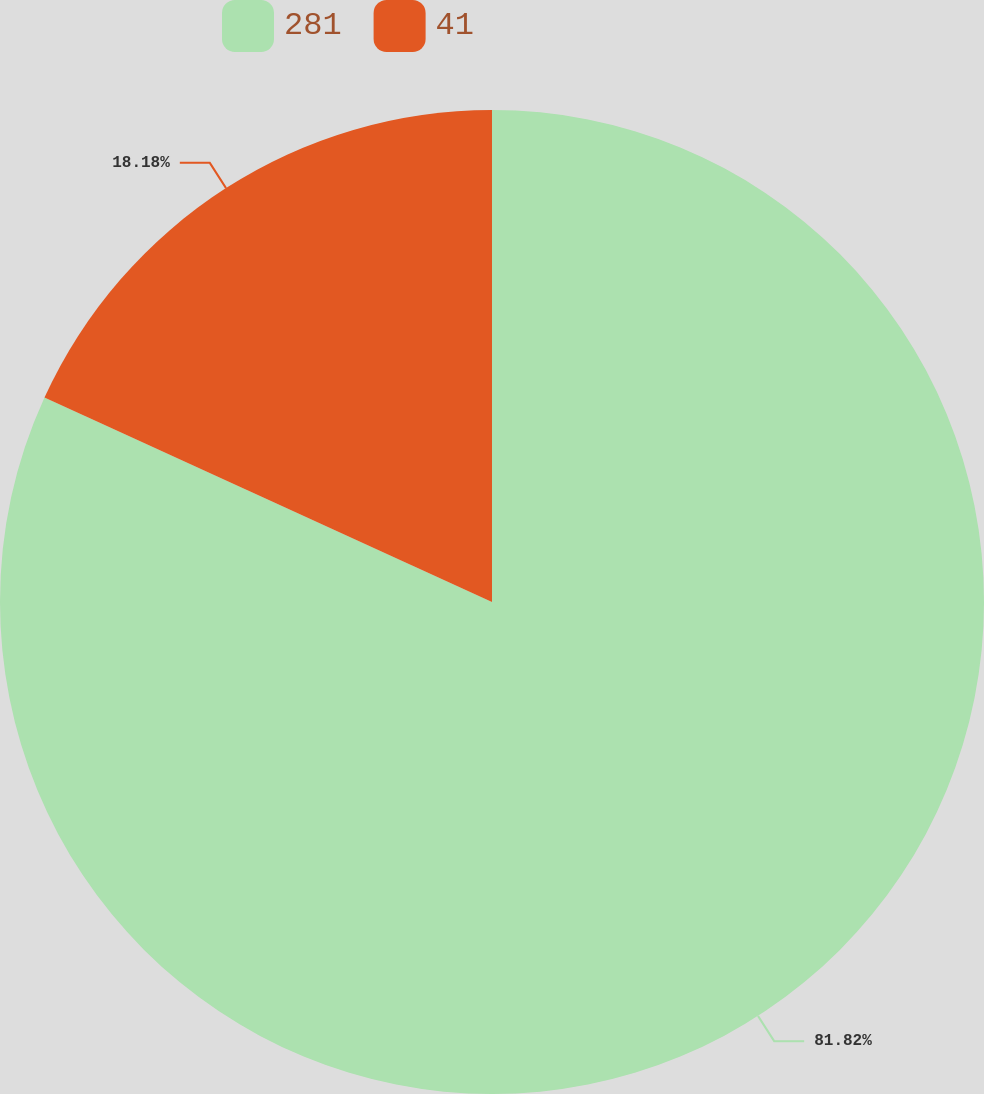<chart> <loc_0><loc_0><loc_500><loc_500><pie_chart><fcel>281<fcel>41<nl><fcel>81.82%<fcel>18.18%<nl></chart> 